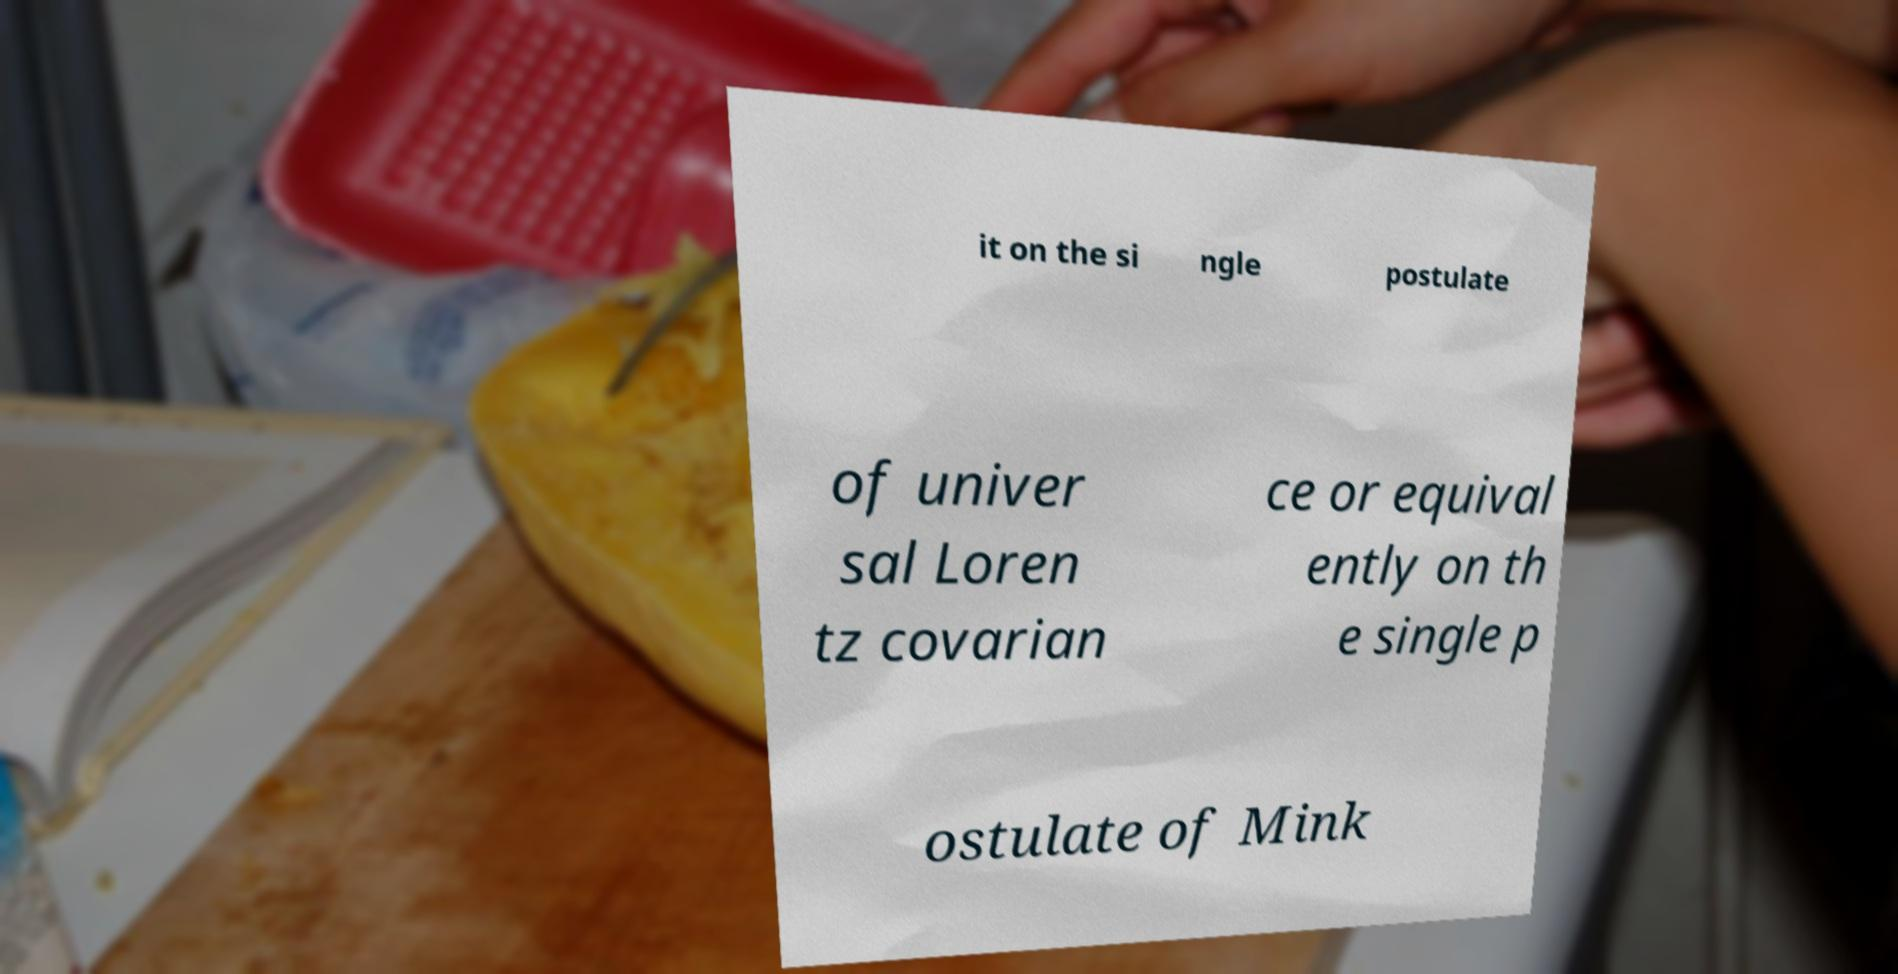For documentation purposes, I need the text within this image transcribed. Could you provide that? it on the si ngle postulate of univer sal Loren tz covarian ce or equival ently on th e single p ostulate of Mink 